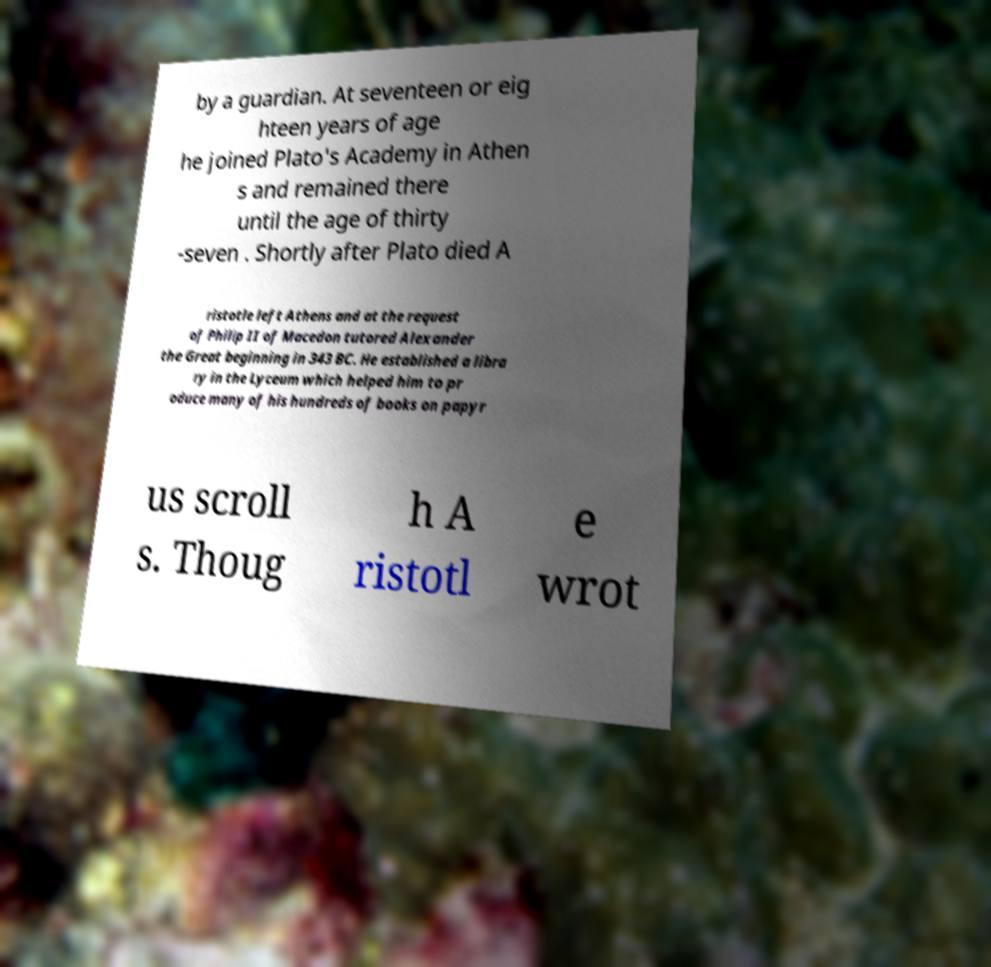Could you extract and type out the text from this image? by a guardian. At seventeen or eig hteen years of age he joined Plato's Academy in Athen s and remained there until the age of thirty -seven . Shortly after Plato died A ristotle left Athens and at the request of Philip II of Macedon tutored Alexander the Great beginning in 343 BC. He established a libra ry in the Lyceum which helped him to pr oduce many of his hundreds of books on papyr us scroll s. Thoug h A ristotl e wrot 